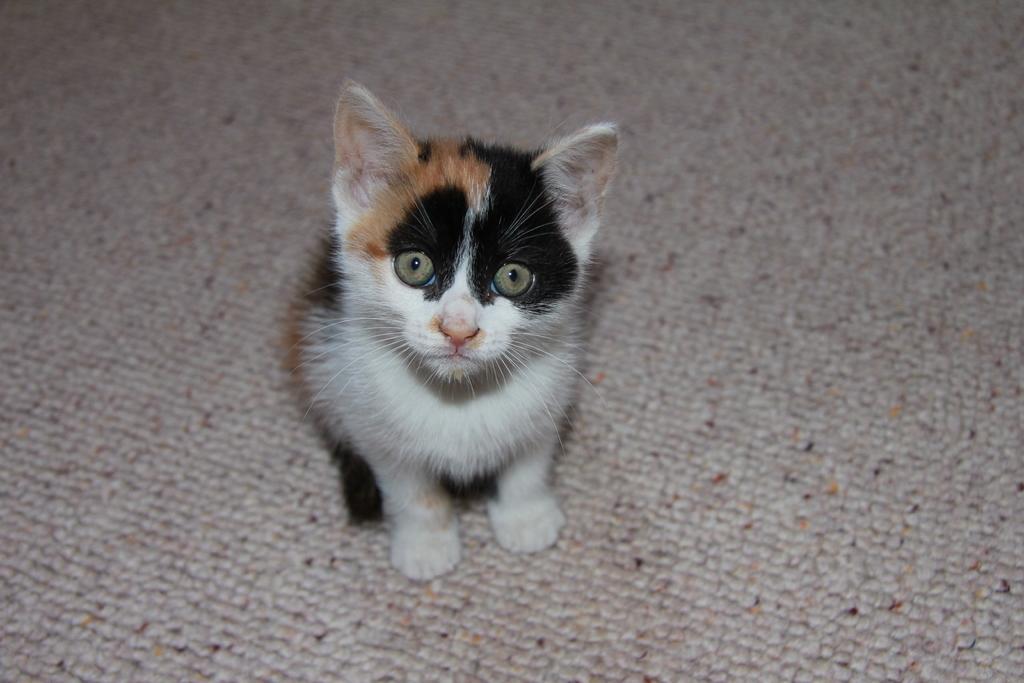In one or two sentences, can you explain what this image depicts? In this image in the center there is one cat, and at the bottom there is carpet. 